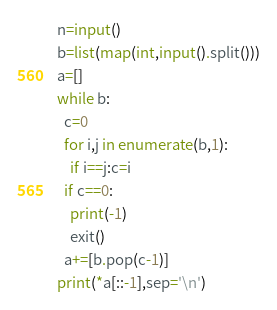Convert code to text. <code><loc_0><loc_0><loc_500><loc_500><_Python_>n=input()
b=list(map(int,input().split()))
a=[]
while b:
  c=0
  for i,j in enumerate(b,1):
    if i==j:c=i
  if c==0:
    print(-1)
    exit()
  a+=[b.pop(c-1)]
print(*a[::-1],sep='\n')</code> 